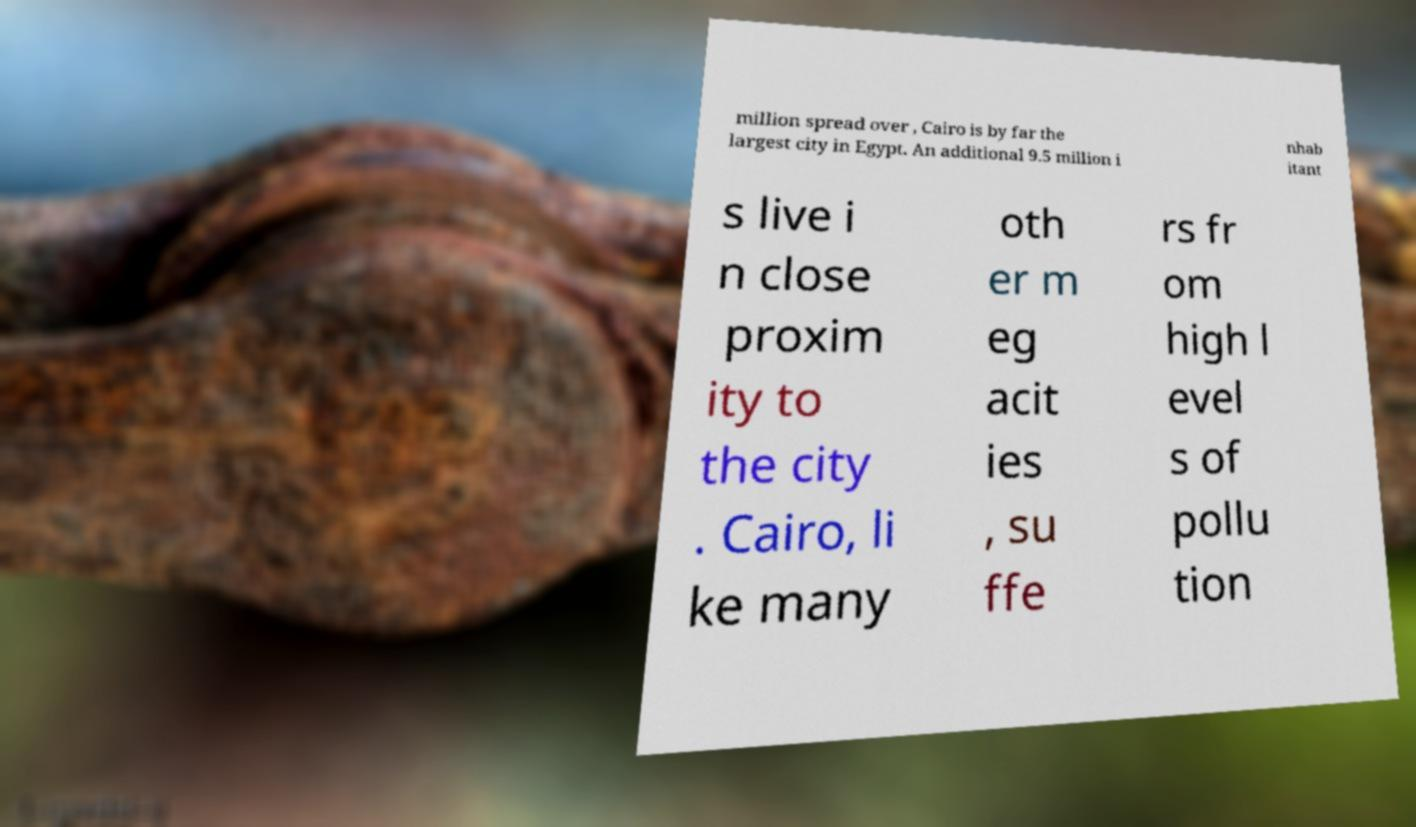Could you extract and type out the text from this image? million spread over , Cairo is by far the largest city in Egypt. An additional 9.5 million i nhab itant s live i n close proxim ity to the city . Cairo, li ke many oth er m eg acit ies , su ffe rs fr om high l evel s of pollu tion 